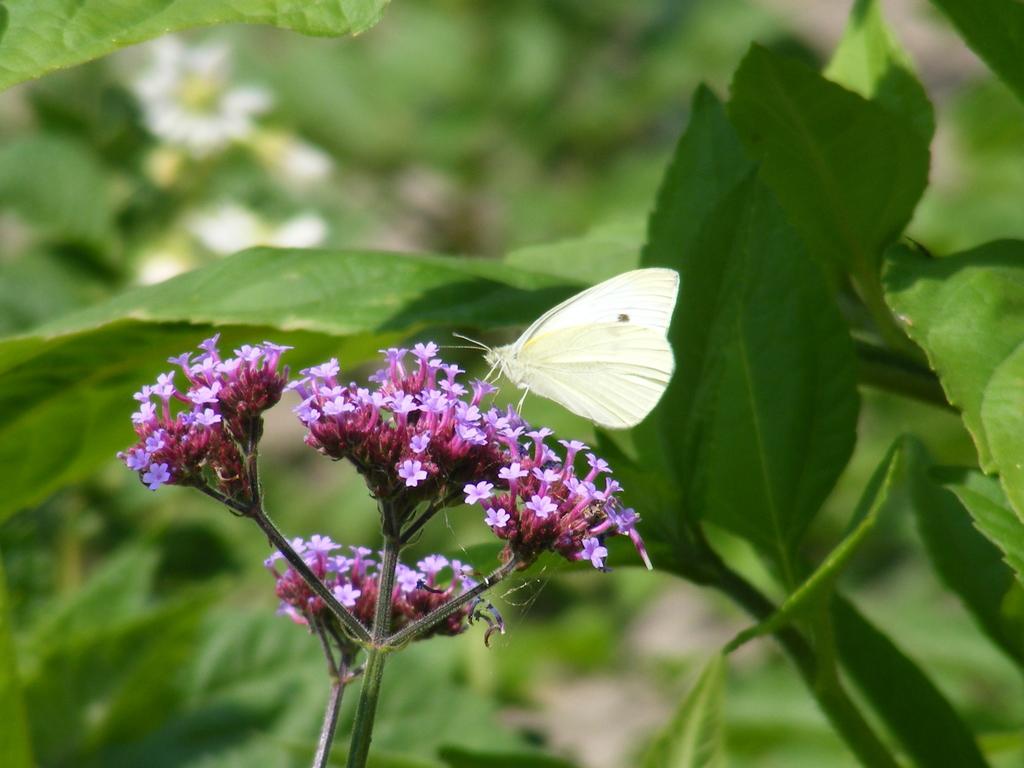Describe this image in one or two sentences. I can see the bunches of flowers to the stem. This looks like a butterfly, which is on the flowers. These are the leaves, which are green in color. 